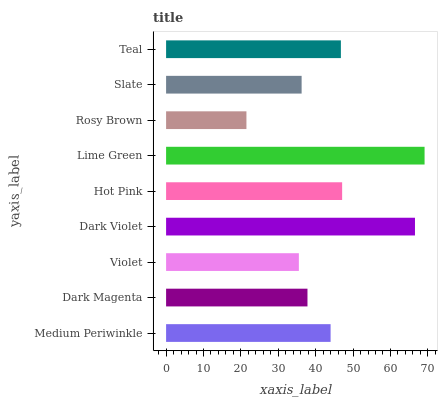Is Rosy Brown the minimum?
Answer yes or no. Yes. Is Lime Green the maximum?
Answer yes or no. Yes. Is Dark Magenta the minimum?
Answer yes or no. No. Is Dark Magenta the maximum?
Answer yes or no. No. Is Medium Periwinkle greater than Dark Magenta?
Answer yes or no. Yes. Is Dark Magenta less than Medium Periwinkle?
Answer yes or no. Yes. Is Dark Magenta greater than Medium Periwinkle?
Answer yes or no. No. Is Medium Periwinkle less than Dark Magenta?
Answer yes or no. No. Is Medium Periwinkle the high median?
Answer yes or no. Yes. Is Medium Periwinkle the low median?
Answer yes or no. Yes. Is Lime Green the high median?
Answer yes or no. No. Is Slate the low median?
Answer yes or no. No. 